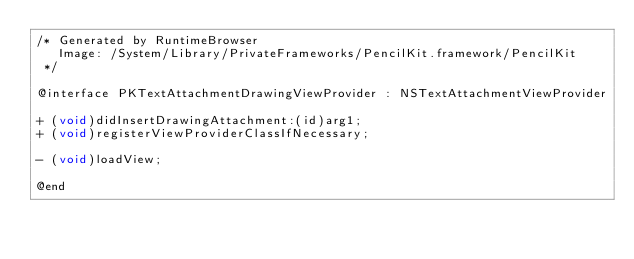<code> <loc_0><loc_0><loc_500><loc_500><_C_>/* Generated by RuntimeBrowser
   Image: /System/Library/PrivateFrameworks/PencilKit.framework/PencilKit
 */

@interface PKTextAttachmentDrawingViewProvider : NSTextAttachmentViewProvider

+ (void)didInsertDrawingAttachment:(id)arg1;
+ (void)registerViewProviderClassIfNecessary;

- (void)loadView;

@end
</code> 